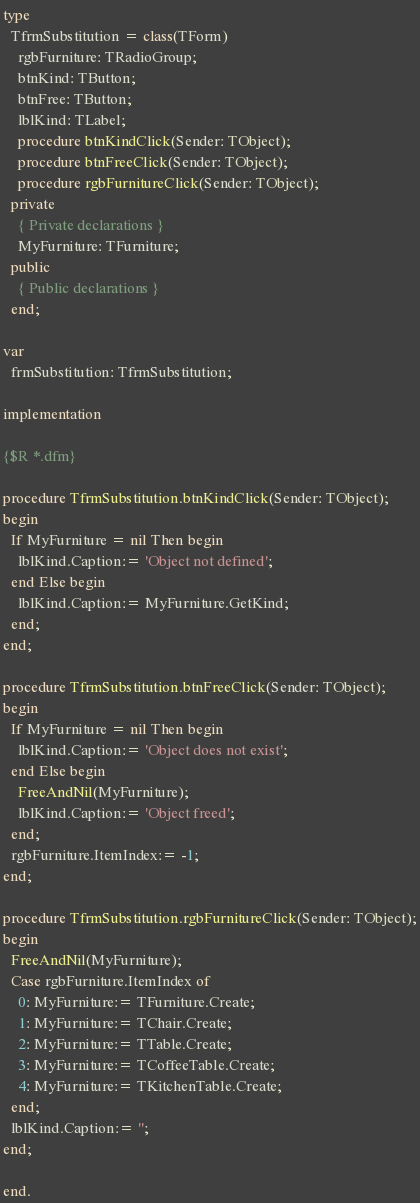Convert code to text. <code><loc_0><loc_0><loc_500><loc_500><_Pascal_>
type
  TfrmSubstitution = class(TForm)
    rgbFurniture: TRadioGroup;
    btnKind: TButton;
    btnFree: TButton;
    lblKind: TLabel;
    procedure btnKindClick(Sender: TObject);
    procedure btnFreeClick(Sender: TObject);
    procedure rgbFurnitureClick(Sender: TObject);
  private
    { Private declarations }
    MyFurniture: TFurniture;
  public
    { Public declarations }
  end;

var
  frmSubstitution: TfrmSubstitution;

implementation

{$R *.dfm}

procedure TfrmSubstitution.btnKindClick(Sender: TObject);
begin
  If MyFurniture = nil Then begin
    lblKind.Caption:= 'Object not defined';
  end Else begin
    lblKind.Caption:= MyFurniture.GetKind;
  end;
end;

procedure TfrmSubstitution.btnFreeClick(Sender: TObject);
begin
  If MyFurniture = nil Then begin
    lblKind.Caption:= 'Object does not exist';
  end Else begin
    FreeAndNil(MyFurniture);
    lblKind.Caption:= 'Object freed';
  end;
  rgbFurniture.ItemIndex:= -1;
end;

procedure TfrmSubstitution.rgbFurnitureClick(Sender: TObject);
begin
  FreeAndNil(MyFurniture);
  Case rgbFurniture.ItemIndex of
    0: MyFurniture:= TFurniture.Create;
    1: MyFurniture:= TChair.Create;
    2: MyFurniture:= TTable.Create;
    3: MyFurniture:= TCoffeeTable.Create;
    4: MyFurniture:= TKitchenTable.Create;
  end;
  lblKind.Caption:= '';
end;

end.
</code> 